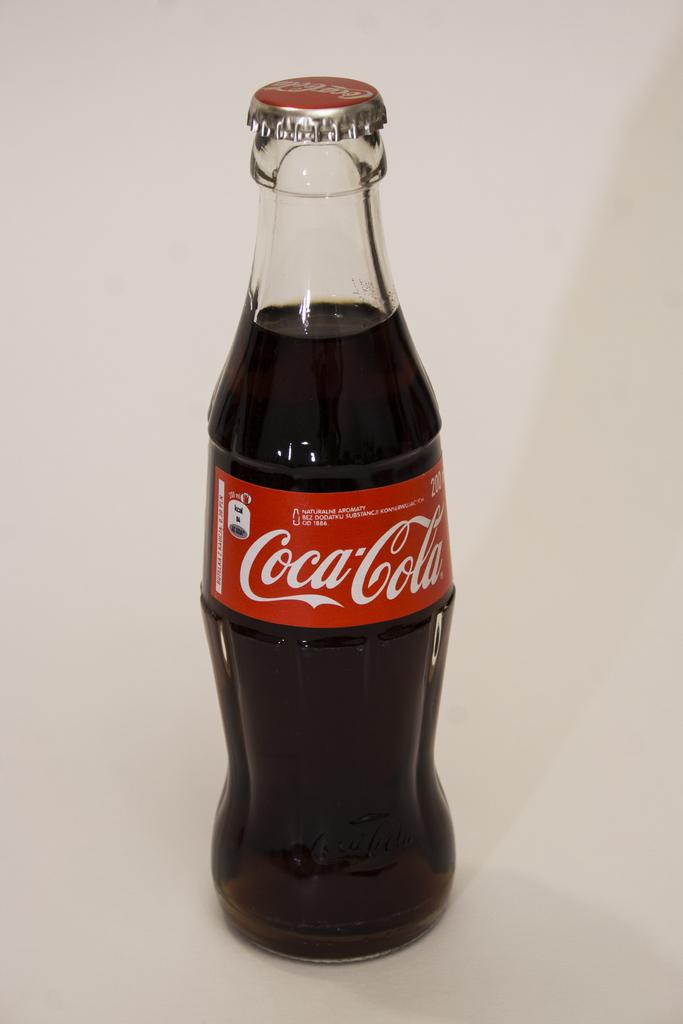What object can be seen in the picture? There is a bottle in the picture. What is inside the bottle? The bottle is filled with a drink. What type of paint is being used to create the seashore scene on the bottle? There is no seashore scene or paint present on the bottle; it is filled with a drink. What advice can be seen written on the bottle? There is no advice written on the bottle; it is a simple bottle filled with a drink. 